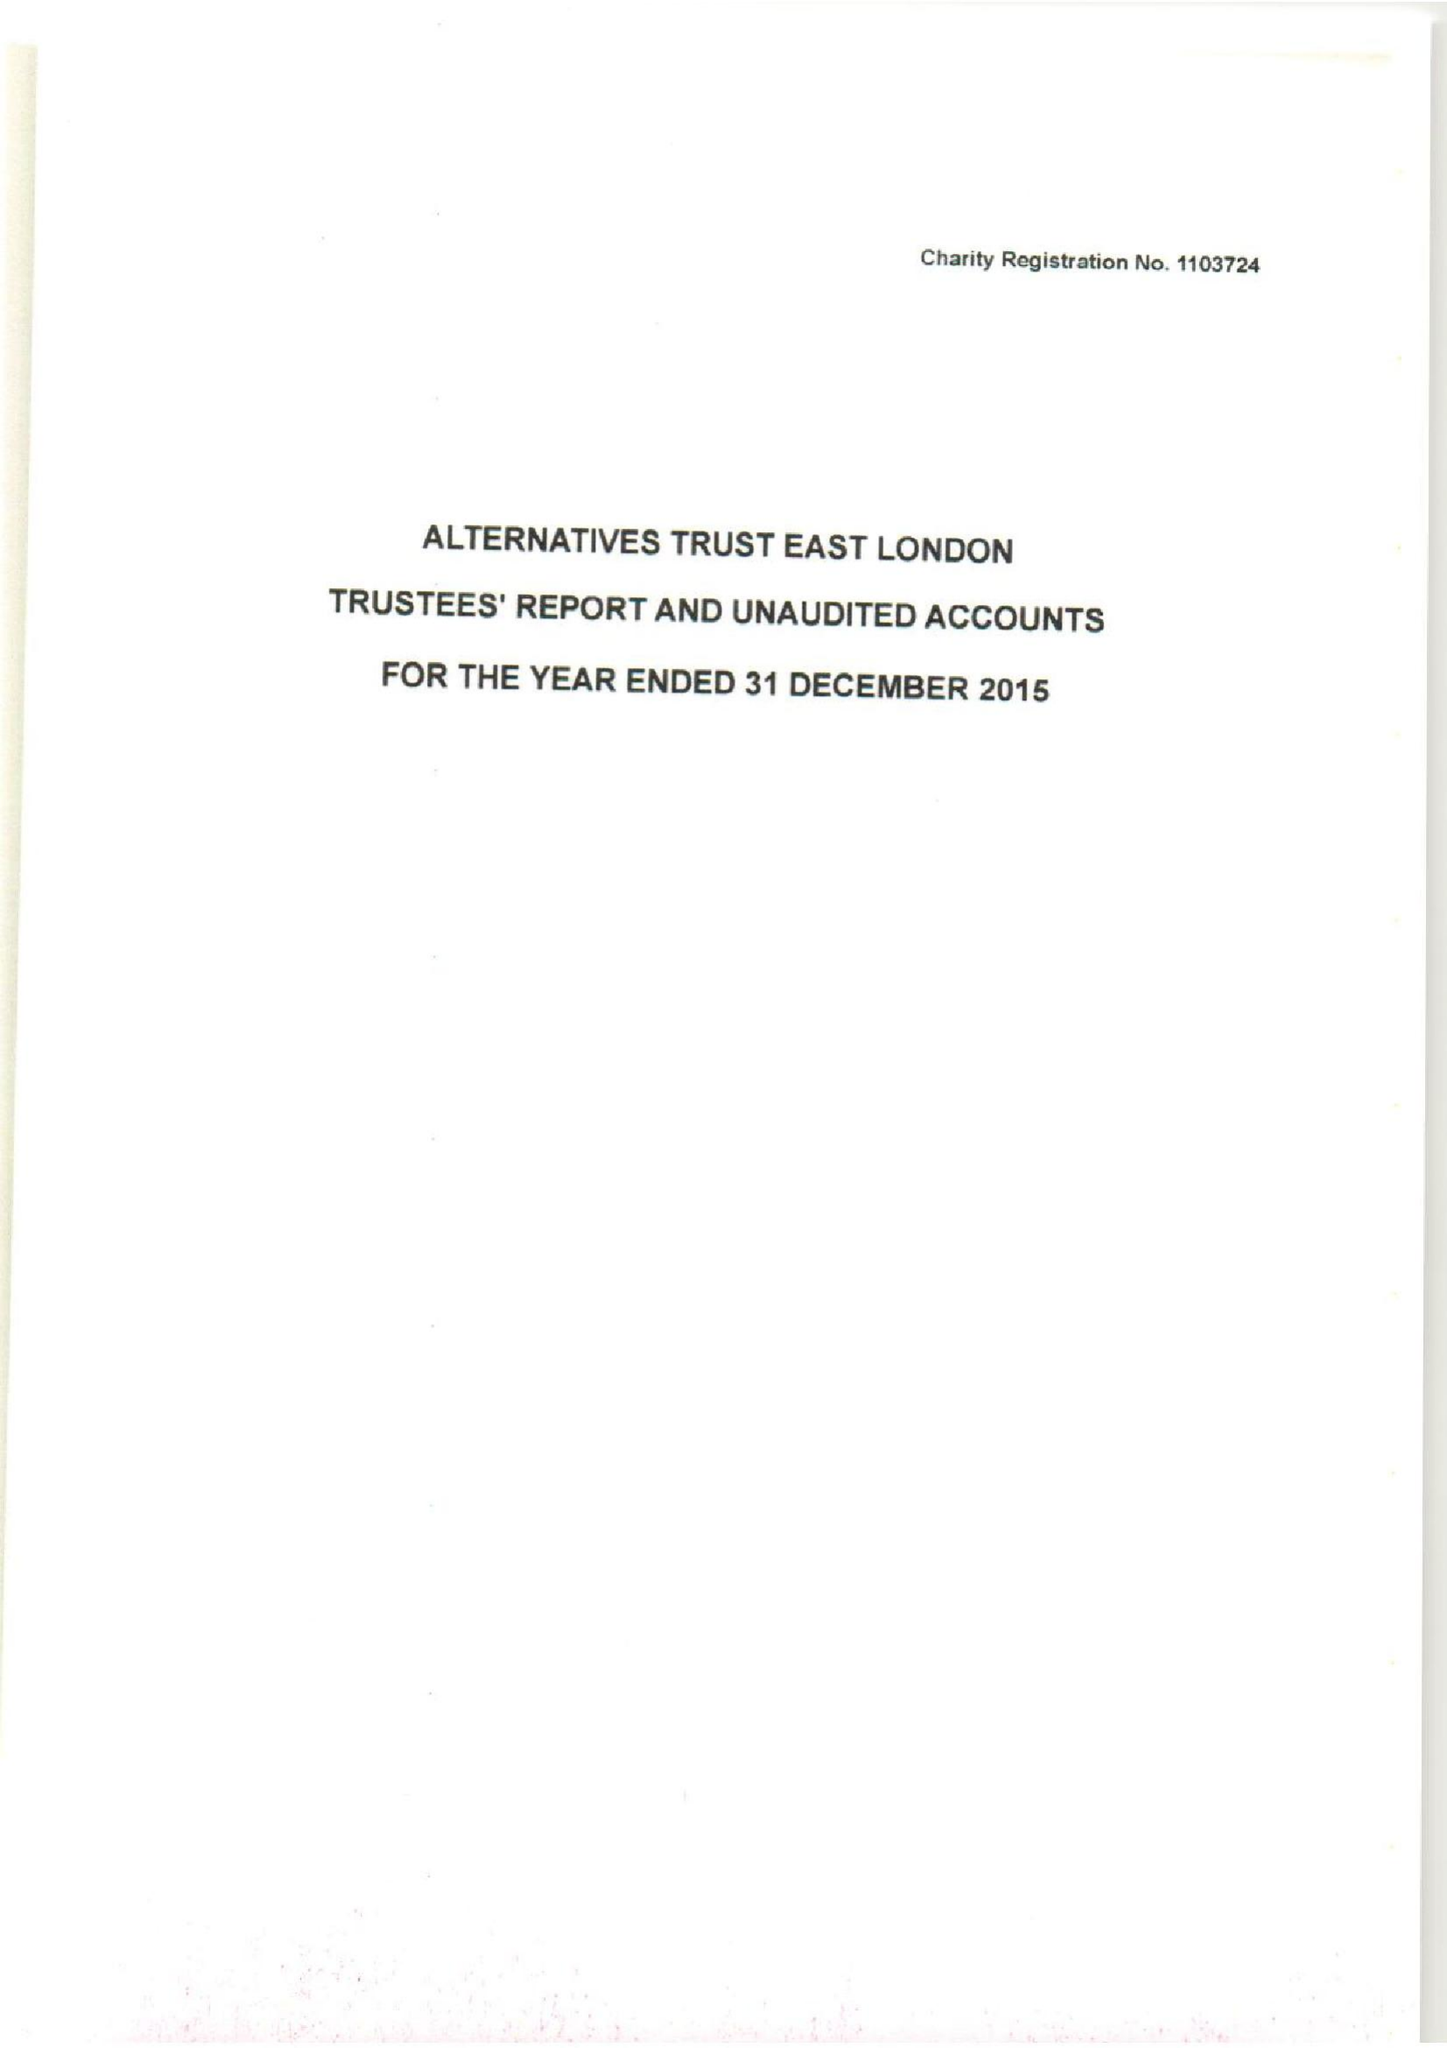What is the value for the address__postcode?
Answer the question using a single word or phrase. E13 8AB 